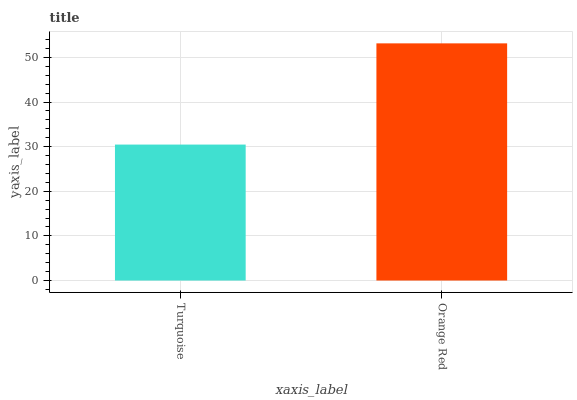Is Turquoise the minimum?
Answer yes or no. Yes. Is Orange Red the maximum?
Answer yes or no. Yes. Is Orange Red the minimum?
Answer yes or no. No. Is Orange Red greater than Turquoise?
Answer yes or no. Yes. Is Turquoise less than Orange Red?
Answer yes or no. Yes. Is Turquoise greater than Orange Red?
Answer yes or no. No. Is Orange Red less than Turquoise?
Answer yes or no. No. Is Orange Red the high median?
Answer yes or no. Yes. Is Turquoise the low median?
Answer yes or no. Yes. Is Turquoise the high median?
Answer yes or no. No. Is Orange Red the low median?
Answer yes or no. No. 